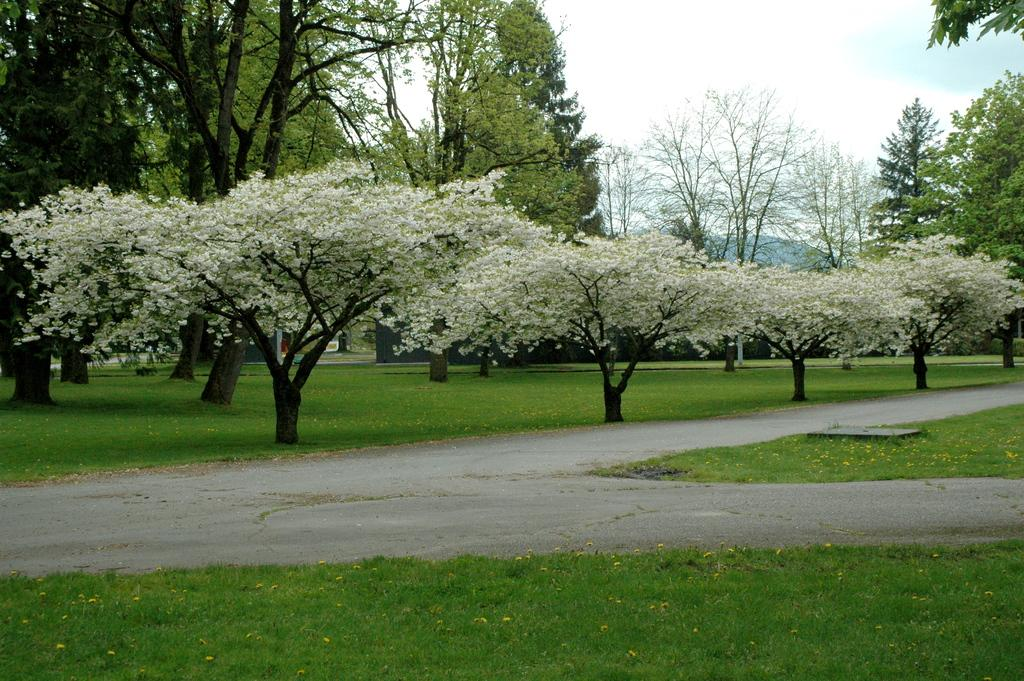What type of surface is at the bottom of the image? There is grass on the surface at the bottom of the image. What is located in the center of the image? There is a road in the center of the image. What can be seen in the background of the image? There are trees and the sky visible in the background of the image. How many beds can be seen in the image? There are no beds present in the image. What type of toy is being played with by the father in the image? There is no father or toy present in the image. 